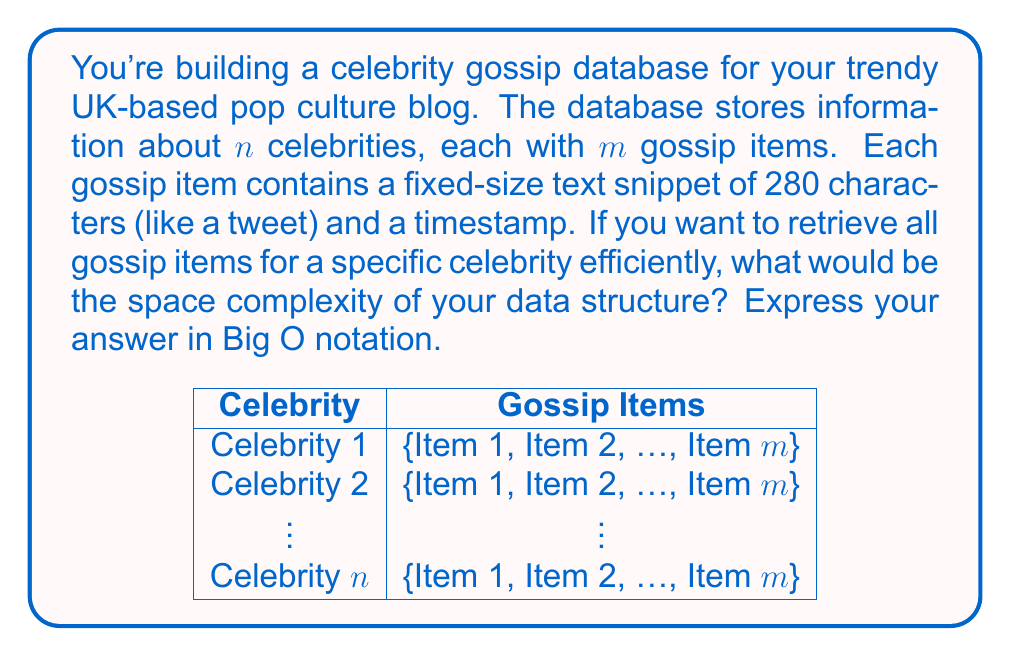Show me your answer to this math problem. Let's break this down step-by-step:

1) First, we need to consider the space required for each gossip item:
   - Text snippet: 280 characters = 280 bytes (assuming 1 byte per character)
   - Timestamp: typically 8 bytes (64-bit integer)
   Total space per gossip item = 280 + 8 = 288 bytes

2) For each celebrity, we have $m$ gossip items:
   Space per celebrity = $m * 288$ bytes

3) We have $n$ celebrities in total:
   Total space = $n * (m * 288)$ bytes

4) To retrieve gossip items efficiently for a specific celebrity, we need an index structure. A simple hash table mapping celebrity IDs to their gossip item lists would suffice.
   The hash table would have $n$ entries, each pointing to a list of $m$ items.

5) The space complexity of the hash table itself would be $O(n)$, as it grows linearly with the number of celebrities.

6) The total space complexity combines the actual data storage and the index structure:
   $O(n * m + n) = O(nm + n) = O(nm)$

   We can simplify to $O(nm)$ because $nm$ will dominate $n$ for any non-trivial number of gossip items per celebrity.

Therefore, the space complexity of storing and efficiently retrieving celebrity gossip data is $O(nm)$, where $n$ is the number of celebrities and $m$ is the number of gossip items per celebrity.
Answer: $O(nm)$ 